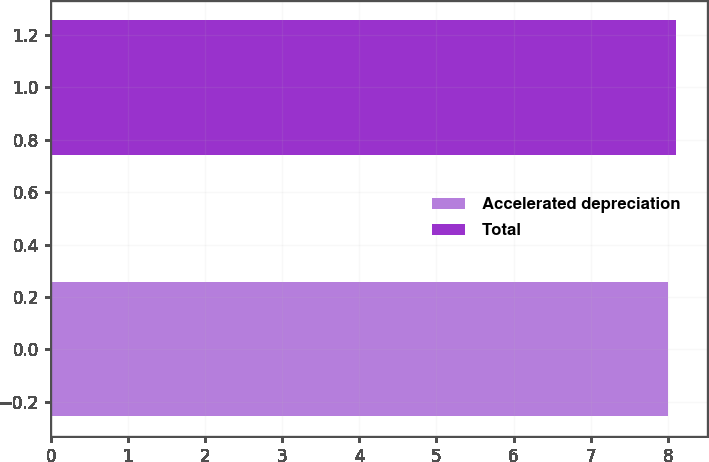<chart> <loc_0><loc_0><loc_500><loc_500><bar_chart><fcel>Accelerated depreciation<fcel>Total<nl><fcel>8<fcel>8.1<nl></chart> 